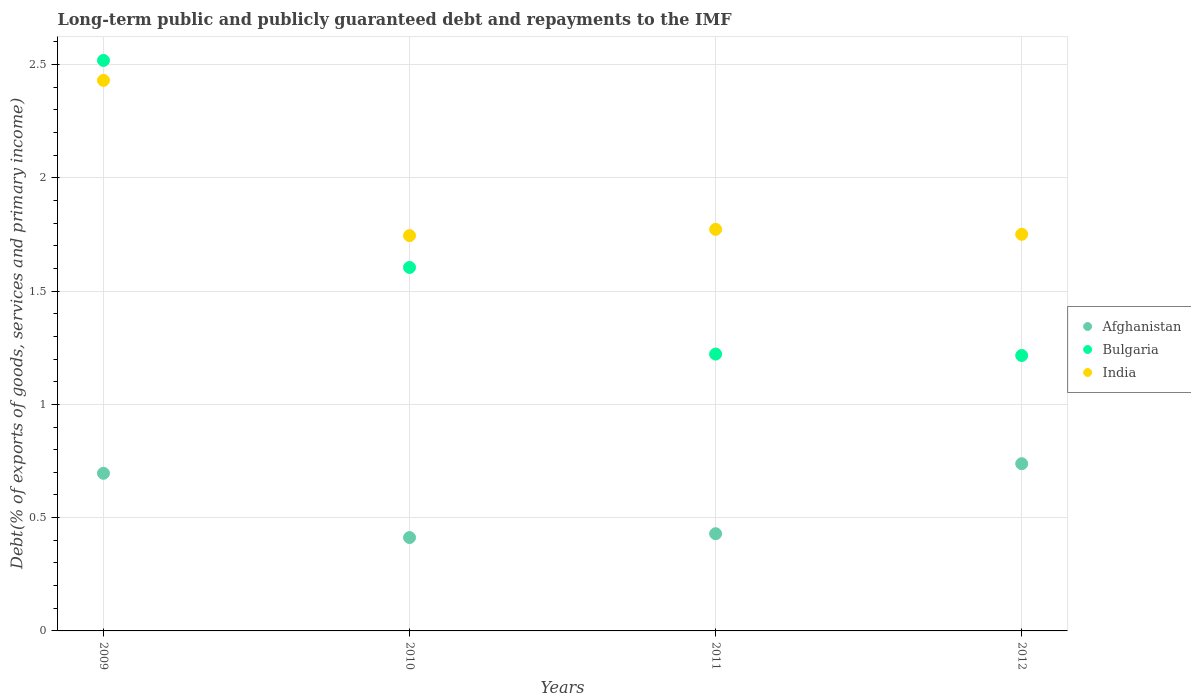Is the number of dotlines equal to the number of legend labels?
Keep it short and to the point. Yes. What is the debt and repayments in Afghanistan in 2010?
Offer a terse response. 0.41. Across all years, what is the maximum debt and repayments in Afghanistan?
Provide a short and direct response. 0.74. Across all years, what is the minimum debt and repayments in India?
Make the answer very short. 1.74. In which year was the debt and repayments in Bulgaria maximum?
Ensure brevity in your answer.  2009. What is the total debt and repayments in Afghanistan in the graph?
Offer a terse response. 2.27. What is the difference between the debt and repayments in Afghanistan in 2009 and that in 2011?
Provide a succinct answer. 0.27. What is the difference between the debt and repayments in India in 2009 and the debt and repayments in Bulgaria in 2010?
Your answer should be very brief. 0.83. What is the average debt and repayments in India per year?
Provide a short and direct response. 1.92. In the year 2009, what is the difference between the debt and repayments in Afghanistan and debt and repayments in India?
Your answer should be compact. -1.73. What is the ratio of the debt and repayments in India in 2009 to that in 2010?
Ensure brevity in your answer.  1.39. What is the difference between the highest and the second highest debt and repayments in India?
Give a very brief answer. 0.66. What is the difference between the highest and the lowest debt and repayments in India?
Give a very brief answer. 0.69. In how many years, is the debt and repayments in Afghanistan greater than the average debt and repayments in Afghanistan taken over all years?
Ensure brevity in your answer.  2. Does the debt and repayments in India monotonically increase over the years?
Ensure brevity in your answer.  No. Is the debt and repayments in Bulgaria strictly less than the debt and repayments in India over the years?
Ensure brevity in your answer.  No. How many dotlines are there?
Provide a short and direct response. 3. Are the values on the major ticks of Y-axis written in scientific E-notation?
Make the answer very short. No. Does the graph contain grids?
Offer a very short reply. Yes. Where does the legend appear in the graph?
Provide a short and direct response. Center right. How many legend labels are there?
Offer a very short reply. 3. How are the legend labels stacked?
Your response must be concise. Vertical. What is the title of the graph?
Provide a short and direct response. Long-term public and publicly guaranteed debt and repayments to the IMF. Does "OECD members" appear as one of the legend labels in the graph?
Your answer should be very brief. No. What is the label or title of the Y-axis?
Offer a terse response. Debt(% of exports of goods, services and primary income). What is the Debt(% of exports of goods, services and primary income) of Afghanistan in 2009?
Offer a terse response. 0.7. What is the Debt(% of exports of goods, services and primary income) of Bulgaria in 2009?
Your answer should be very brief. 2.52. What is the Debt(% of exports of goods, services and primary income) of India in 2009?
Provide a succinct answer. 2.43. What is the Debt(% of exports of goods, services and primary income) of Afghanistan in 2010?
Offer a terse response. 0.41. What is the Debt(% of exports of goods, services and primary income) of Bulgaria in 2010?
Ensure brevity in your answer.  1.6. What is the Debt(% of exports of goods, services and primary income) of India in 2010?
Offer a very short reply. 1.74. What is the Debt(% of exports of goods, services and primary income) in Afghanistan in 2011?
Your answer should be compact. 0.43. What is the Debt(% of exports of goods, services and primary income) in Bulgaria in 2011?
Keep it short and to the point. 1.22. What is the Debt(% of exports of goods, services and primary income) of India in 2011?
Keep it short and to the point. 1.77. What is the Debt(% of exports of goods, services and primary income) of Afghanistan in 2012?
Offer a terse response. 0.74. What is the Debt(% of exports of goods, services and primary income) in Bulgaria in 2012?
Ensure brevity in your answer.  1.22. What is the Debt(% of exports of goods, services and primary income) of India in 2012?
Offer a very short reply. 1.75. Across all years, what is the maximum Debt(% of exports of goods, services and primary income) of Afghanistan?
Keep it short and to the point. 0.74. Across all years, what is the maximum Debt(% of exports of goods, services and primary income) of Bulgaria?
Your answer should be compact. 2.52. Across all years, what is the maximum Debt(% of exports of goods, services and primary income) in India?
Your response must be concise. 2.43. Across all years, what is the minimum Debt(% of exports of goods, services and primary income) of Afghanistan?
Offer a very short reply. 0.41. Across all years, what is the minimum Debt(% of exports of goods, services and primary income) in Bulgaria?
Ensure brevity in your answer.  1.22. Across all years, what is the minimum Debt(% of exports of goods, services and primary income) in India?
Your answer should be very brief. 1.74. What is the total Debt(% of exports of goods, services and primary income) in Afghanistan in the graph?
Ensure brevity in your answer.  2.27. What is the total Debt(% of exports of goods, services and primary income) of Bulgaria in the graph?
Offer a very short reply. 6.56. What is the total Debt(% of exports of goods, services and primary income) of India in the graph?
Keep it short and to the point. 7.7. What is the difference between the Debt(% of exports of goods, services and primary income) in Afghanistan in 2009 and that in 2010?
Give a very brief answer. 0.28. What is the difference between the Debt(% of exports of goods, services and primary income) of Bulgaria in 2009 and that in 2010?
Your answer should be very brief. 0.91. What is the difference between the Debt(% of exports of goods, services and primary income) of India in 2009 and that in 2010?
Your response must be concise. 0.69. What is the difference between the Debt(% of exports of goods, services and primary income) in Afghanistan in 2009 and that in 2011?
Provide a short and direct response. 0.27. What is the difference between the Debt(% of exports of goods, services and primary income) in Bulgaria in 2009 and that in 2011?
Offer a terse response. 1.3. What is the difference between the Debt(% of exports of goods, services and primary income) of India in 2009 and that in 2011?
Provide a succinct answer. 0.66. What is the difference between the Debt(% of exports of goods, services and primary income) of Afghanistan in 2009 and that in 2012?
Provide a succinct answer. -0.04. What is the difference between the Debt(% of exports of goods, services and primary income) in Bulgaria in 2009 and that in 2012?
Keep it short and to the point. 1.3. What is the difference between the Debt(% of exports of goods, services and primary income) of India in 2009 and that in 2012?
Your answer should be very brief. 0.68. What is the difference between the Debt(% of exports of goods, services and primary income) of Afghanistan in 2010 and that in 2011?
Provide a succinct answer. -0.02. What is the difference between the Debt(% of exports of goods, services and primary income) of Bulgaria in 2010 and that in 2011?
Ensure brevity in your answer.  0.38. What is the difference between the Debt(% of exports of goods, services and primary income) in India in 2010 and that in 2011?
Offer a very short reply. -0.03. What is the difference between the Debt(% of exports of goods, services and primary income) in Afghanistan in 2010 and that in 2012?
Give a very brief answer. -0.33. What is the difference between the Debt(% of exports of goods, services and primary income) in Bulgaria in 2010 and that in 2012?
Offer a terse response. 0.39. What is the difference between the Debt(% of exports of goods, services and primary income) in India in 2010 and that in 2012?
Your answer should be very brief. -0.01. What is the difference between the Debt(% of exports of goods, services and primary income) of Afghanistan in 2011 and that in 2012?
Offer a terse response. -0.31. What is the difference between the Debt(% of exports of goods, services and primary income) of Bulgaria in 2011 and that in 2012?
Give a very brief answer. 0.01. What is the difference between the Debt(% of exports of goods, services and primary income) in India in 2011 and that in 2012?
Keep it short and to the point. 0.02. What is the difference between the Debt(% of exports of goods, services and primary income) of Afghanistan in 2009 and the Debt(% of exports of goods, services and primary income) of Bulgaria in 2010?
Provide a succinct answer. -0.91. What is the difference between the Debt(% of exports of goods, services and primary income) of Afghanistan in 2009 and the Debt(% of exports of goods, services and primary income) of India in 2010?
Your answer should be compact. -1.05. What is the difference between the Debt(% of exports of goods, services and primary income) in Bulgaria in 2009 and the Debt(% of exports of goods, services and primary income) in India in 2010?
Ensure brevity in your answer.  0.77. What is the difference between the Debt(% of exports of goods, services and primary income) of Afghanistan in 2009 and the Debt(% of exports of goods, services and primary income) of Bulgaria in 2011?
Keep it short and to the point. -0.53. What is the difference between the Debt(% of exports of goods, services and primary income) in Afghanistan in 2009 and the Debt(% of exports of goods, services and primary income) in India in 2011?
Your answer should be compact. -1.08. What is the difference between the Debt(% of exports of goods, services and primary income) in Bulgaria in 2009 and the Debt(% of exports of goods, services and primary income) in India in 2011?
Your response must be concise. 0.75. What is the difference between the Debt(% of exports of goods, services and primary income) in Afghanistan in 2009 and the Debt(% of exports of goods, services and primary income) in Bulgaria in 2012?
Your response must be concise. -0.52. What is the difference between the Debt(% of exports of goods, services and primary income) in Afghanistan in 2009 and the Debt(% of exports of goods, services and primary income) in India in 2012?
Ensure brevity in your answer.  -1.05. What is the difference between the Debt(% of exports of goods, services and primary income) of Bulgaria in 2009 and the Debt(% of exports of goods, services and primary income) of India in 2012?
Keep it short and to the point. 0.77. What is the difference between the Debt(% of exports of goods, services and primary income) of Afghanistan in 2010 and the Debt(% of exports of goods, services and primary income) of Bulgaria in 2011?
Provide a succinct answer. -0.81. What is the difference between the Debt(% of exports of goods, services and primary income) in Afghanistan in 2010 and the Debt(% of exports of goods, services and primary income) in India in 2011?
Your answer should be compact. -1.36. What is the difference between the Debt(% of exports of goods, services and primary income) of Bulgaria in 2010 and the Debt(% of exports of goods, services and primary income) of India in 2011?
Your answer should be very brief. -0.17. What is the difference between the Debt(% of exports of goods, services and primary income) of Afghanistan in 2010 and the Debt(% of exports of goods, services and primary income) of Bulgaria in 2012?
Give a very brief answer. -0.8. What is the difference between the Debt(% of exports of goods, services and primary income) of Afghanistan in 2010 and the Debt(% of exports of goods, services and primary income) of India in 2012?
Your answer should be very brief. -1.34. What is the difference between the Debt(% of exports of goods, services and primary income) in Bulgaria in 2010 and the Debt(% of exports of goods, services and primary income) in India in 2012?
Your response must be concise. -0.15. What is the difference between the Debt(% of exports of goods, services and primary income) in Afghanistan in 2011 and the Debt(% of exports of goods, services and primary income) in Bulgaria in 2012?
Give a very brief answer. -0.79. What is the difference between the Debt(% of exports of goods, services and primary income) of Afghanistan in 2011 and the Debt(% of exports of goods, services and primary income) of India in 2012?
Your answer should be compact. -1.32. What is the difference between the Debt(% of exports of goods, services and primary income) of Bulgaria in 2011 and the Debt(% of exports of goods, services and primary income) of India in 2012?
Keep it short and to the point. -0.53. What is the average Debt(% of exports of goods, services and primary income) in Afghanistan per year?
Keep it short and to the point. 0.57. What is the average Debt(% of exports of goods, services and primary income) of Bulgaria per year?
Make the answer very short. 1.64. What is the average Debt(% of exports of goods, services and primary income) of India per year?
Make the answer very short. 1.92. In the year 2009, what is the difference between the Debt(% of exports of goods, services and primary income) of Afghanistan and Debt(% of exports of goods, services and primary income) of Bulgaria?
Offer a very short reply. -1.82. In the year 2009, what is the difference between the Debt(% of exports of goods, services and primary income) in Afghanistan and Debt(% of exports of goods, services and primary income) in India?
Ensure brevity in your answer.  -1.73. In the year 2009, what is the difference between the Debt(% of exports of goods, services and primary income) in Bulgaria and Debt(% of exports of goods, services and primary income) in India?
Offer a terse response. 0.09. In the year 2010, what is the difference between the Debt(% of exports of goods, services and primary income) of Afghanistan and Debt(% of exports of goods, services and primary income) of Bulgaria?
Offer a very short reply. -1.19. In the year 2010, what is the difference between the Debt(% of exports of goods, services and primary income) of Afghanistan and Debt(% of exports of goods, services and primary income) of India?
Make the answer very short. -1.33. In the year 2010, what is the difference between the Debt(% of exports of goods, services and primary income) of Bulgaria and Debt(% of exports of goods, services and primary income) of India?
Provide a short and direct response. -0.14. In the year 2011, what is the difference between the Debt(% of exports of goods, services and primary income) in Afghanistan and Debt(% of exports of goods, services and primary income) in Bulgaria?
Offer a terse response. -0.79. In the year 2011, what is the difference between the Debt(% of exports of goods, services and primary income) in Afghanistan and Debt(% of exports of goods, services and primary income) in India?
Make the answer very short. -1.34. In the year 2011, what is the difference between the Debt(% of exports of goods, services and primary income) in Bulgaria and Debt(% of exports of goods, services and primary income) in India?
Give a very brief answer. -0.55. In the year 2012, what is the difference between the Debt(% of exports of goods, services and primary income) of Afghanistan and Debt(% of exports of goods, services and primary income) of Bulgaria?
Provide a succinct answer. -0.48. In the year 2012, what is the difference between the Debt(% of exports of goods, services and primary income) in Afghanistan and Debt(% of exports of goods, services and primary income) in India?
Make the answer very short. -1.01. In the year 2012, what is the difference between the Debt(% of exports of goods, services and primary income) of Bulgaria and Debt(% of exports of goods, services and primary income) of India?
Keep it short and to the point. -0.54. What is the ratio of the Debt(% of exports of goods, services and primary income) of Afghanistan in 2009 to that in 2010?
Provide a succinct answer. 1.69. What is the ratio of the Debt(% of exports of goods, services and primary income) in Bulgaria in 2009 to that in 2010?
Give a very brief answer. 1.57. What is the ratio of the Debt(% of exports of goods, services and primary income) in India in 2009 to that in 2010?
Provide a short and direct response. 1.39. What is the ratio of the Debt(% of exports of goods, services and primary income) of Afghanistan in 2009 to that in 2011?
Keep it short and to the point. 1.62. What is the ratio of the Debt(% of exports of goods, services and primary income) in Bulgaria in 2009 to that in 2011?
Provide a succinct answer. 2.06. What is the ratio of the Debt(% of exports of goods, services and primary income) in India in 2009 to that in 2011?
Your answer should be very brief. 1.37. What is the ratio of the Debt(% of exports of goods, services and primary income) of Afghanistan in 2009 to that in 2012?
Your answer should be compact. 0.94. What is the ratio of the Debt(% of exports of goods, services and primary income) in Bulgaria in 2009 to that in 2012?
Your response must be concise. 2.07. What is the ratio of the Debt(% of exports of goods, services and primary income) of India in 2009 to that in 2012?
Provide a short and direct response. 1.39. What is the ratio of the Debt(% of exports of goods, services and primary income) of Afghanistan in 2010 to that in 2011?
Provide a succinct answer. 0.96. What is the ratio of the Debt(% of exports of goods, services and primary income) of Bulgaria in 2010 to that in 2011?
Provide a short and direct response. 1.31. What is the ratio of the Debt(% of exports of goods, services and primary income) in India in 2010 to that in 2011?
Offer a terse response. 0.98. What is the ratio of the Debt(% of exports of goods, services and primary income) in Afghanistan in 2010 to that in 2012?
Give a very brief answer. 0.56. What is the ratio of the Debt(% of exports of goods, services and primary income) of Bulgaria in 2010 to that in 2012?
Ensure brevity in your answer.  1.32. What is the ratio of the Debt(% of exports of goods, services and primary income) in India in 2010 to that in 2012?
Provide a short and direct response. 1. What is the ratio of the Debt(% of exports of goods, services and primary income) of Afghanistan in 2011 to that in 2012?
Keep it short and to the point. 0.58. What is the ratio of the Debt(% of exports of goods, services and primary income) in Bulgaria in 2011 to that in 2012?
Give a very brief answer. 1.01. What is the ratio of the Debt(% of exports of goods, services and primary income) of India in 2011 to that in 2012?
Provide a succinct answer. 1.01. What is the difference between the highest and the second highest Debt(% of exports of goods, services and primary income) in Afghanistan?
Ensure brevity in your answer.  0.04. What is the difference between the highest and the second highest Debt(% of exports of goods, services and primary income) of Bulgaria?
Keep it short and to the point. 0.91. What is the difference between the highest and the second highest Debt(% of exports of goods, services and primary income) of India?
Your answer should be very brief. 0.66. What is the difference between the highest and the lowest Debt(% of exports of goods, services and primary income) of Afghanistan?
Make the answer very short. 0.33. What is the difference between the highest and the lowest Debt(% of exports of goods, services and primary income) of Bulgaria?
Your answer should be compact. 1.3. What is the difference between the highest and the lowest Debt(% of exports of goods, services and primary income) in India?
Keep it short and to the point. 0.69. 